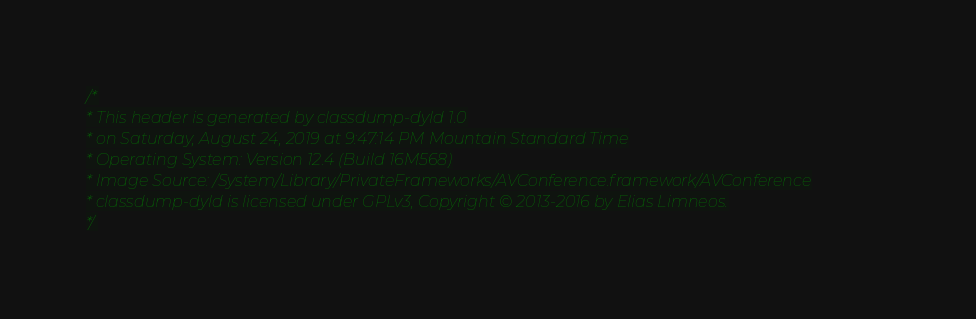<code> <loc_0><loc_0><loc_500><loc_500><_C_>/*
* This header is generated by classdump-dyld 1.0
* on Saturday, August 24, 2019 at 9:47:14 PM Mountain Standard Time
* Operating System: Version 12.4 (Build 16M568)
* Image Source: /System/Library/PrivateFrameworks/AVConference.framework/AVConference
* classdump-dyld is licensed under GPLv3, Copyright © 2013-2016 by Elias Limneos.
*/

</code> 